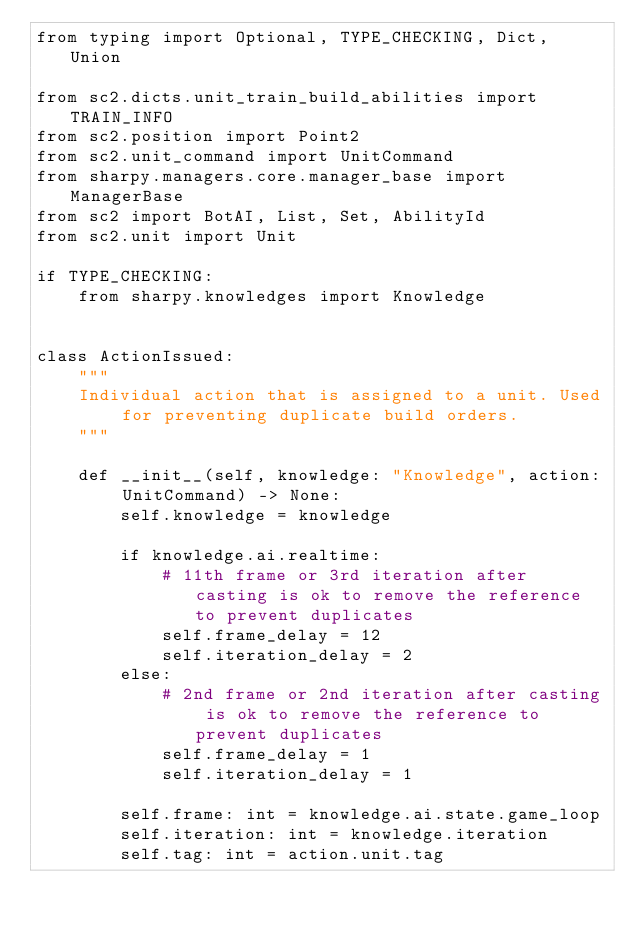Convert code to text. <code><loc_0><loc_0><loc_500><loc_500><_Python_>from typing import Optional, TYPE_CHECKING, Dict, Union

from sc2.dicts.unit_train_build_abilities import TRAIN_INFO
from sc2.position import Point2
from sc2.unit_command import UnitCommand
from sharpy.managers.core.manager_base import ManagerBase
from sc2 import BotAI, List, Set, AbilityId
from sc2.unit import Unit

if TYPE_CHECKING:
    from sharpy.knowledges import Knowledge


class ActionIssued:
    """
    Individual action that is assigned to a unit. Used for preventing duplicate build orders.
    """

    def __init__(self, knowledge: "Knowledge", action: UnitCommand) -> None:
        self.knowledge = knowledge

        if knowledge.ai.realtime:
            # 11th frame or 3rd iteration after casting is ok to remove the reference to prevent duplicates
            self.frame_delay = 12
            self.iteration_delay = 2
        else:
            # 2nd frame or 2nd iteration after casting is ok to remove the reference to prevent duplicates
            self.frame_delay = 1
            self.iteration_delay = 1

        self.frame: int = knowledge.ai.state.game_loop
        self.iteration: int = knowledge.iteration
        self.tag: int = action.unit.tag</code> 